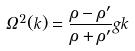Convert formula to latex. <formula><loc_0><loc_0><loc_500><loc_500>\Omega ^ { 2 } ( k ) = \frac { \rho - \rho ^ { \prime } } { \rho + \rho ^ { \prime } } g k</formula> 